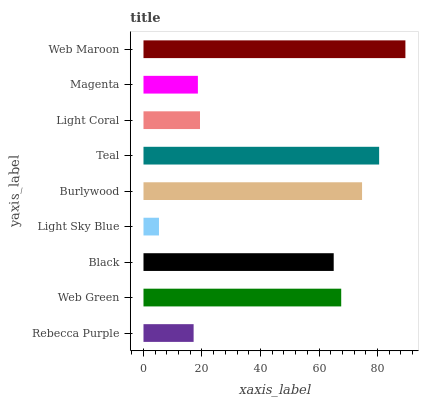Is Light Sky Blue the minimum?
Answer yes or no. Yes. Is Web Maroon the maximum?
Answer yes or no. Yes. Is Web Green the minimum?
Answer yes or no. No. Is Web Green the maximum?
Answer yes or no. No. Is Web Green greater than Rebecca Purple?
Answer yes or no. Yes. Is Rebecca Purple less than Web Green?
Answer yes or no. Yes. Is Rebecca Purple greater than Web Green?
Answer yes or no. No. Is Web Green less than Rebecca Purple?
Answer yes or no. No. Is Black the high median?
Answer yes or no. Yes. Is Black the low median?
Answer yes or no. Yes. Is Burlywood the high median?
Answer yes or no. No. Is Teal the low median?
Answer yes or no. No. 